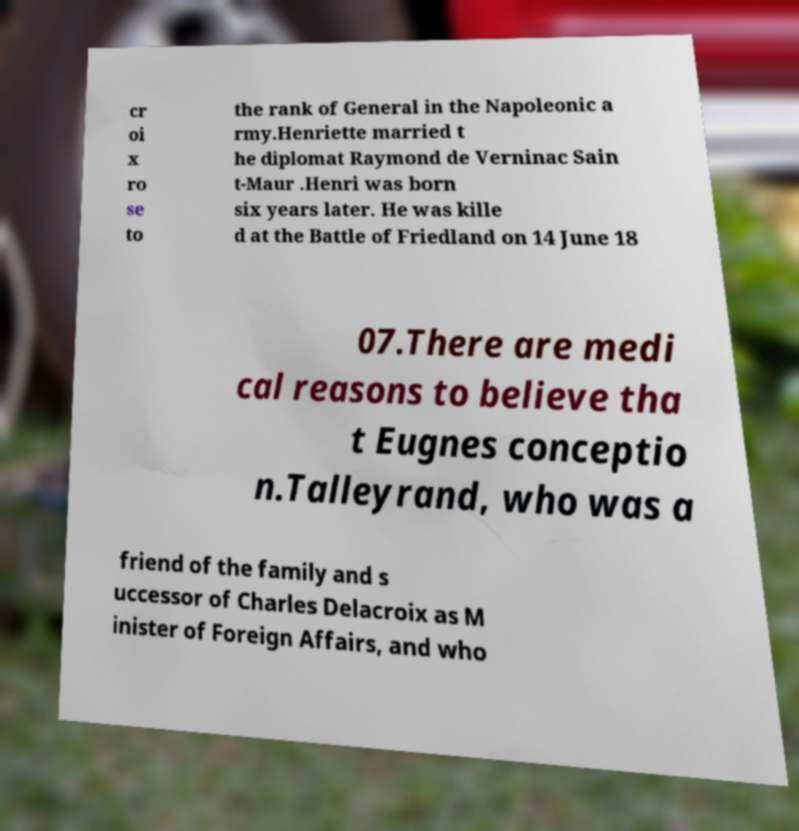Could you extract and type out the text from this image? cr oi x ro se to the rank of General in the Napoleonic a rmy.Henriette married t he diplomat Raymond de Verninac Sain t-Maur .Henri was born six years later. He was kille d at the Battle of Friedland on 14 June 18 07.There are medi cal reasons to believe tha t Eugnes conceptio n.Talleyrand, who was a friend of the family and s uccessor of Charles Delacroix as M inister of Foreign Affairs, and who 